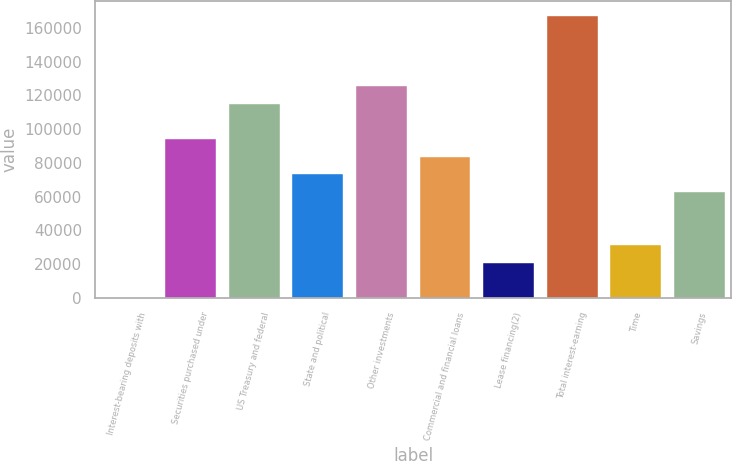Convert chart to OTSL. <chart><loc_0><loc_0><loc_500><loc_500><bar_chart><fcel>Interest-bearing deposits with<fcel>Securities purchased under<fcel>US Treasury and federal<fcel>State and political<fcel>Other investments<fcel>Commercial and financial loans<fcel>Lease financing(2)<fcel>Total interest-earning<fcel>Time<fcel>Savings<nl><fcel>13<fcel>94096.3<fcel>115004<fcel>73188.9<fcel>125457<fcel>83642.6<fcel>20920.4<fcel>167272<fcel>31374.1<fcel>62735.2<nl></chart> 